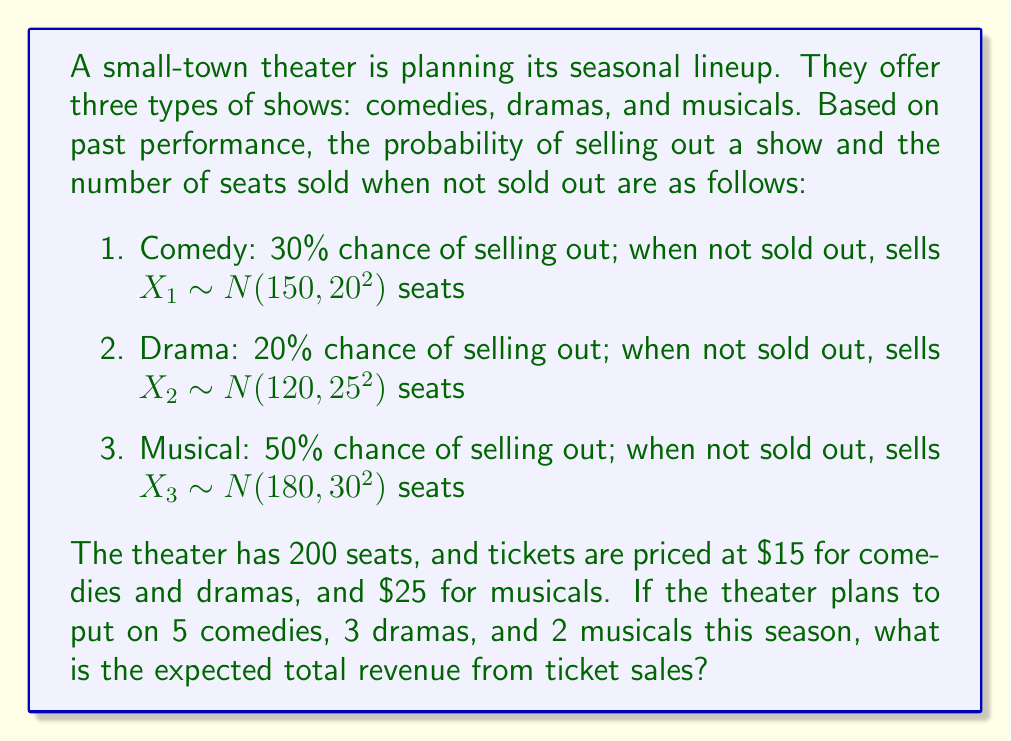Teach me how to tackle this problem. Let's approach this step-by-step:

1) First, we need to calculate the expected revenue for each type of show:

   For Comedy:
   $E(R_c) = 0.3 \cdot (200 \cdot \$15) + 0.7 \cdot (E(X_1) \cdot \$15)$
   $E(X_1) = 150$ (mean of the normal distribution)
   $E(R_c) = 0.3 \cdot \$3000 + 0.7 \cdot (150 \cdot \$15) = \$2475$

   For Drama:
   $E(R_d) = 0.2 \cdot (200 \cdot \$15) + 0.8 \cdot (E(X_2) \cdot \$15)$
   $E(X_2) = 120$
   $E(R_d) = 0.2 \cdot \$3000 + 0.8 \cdot (120 \cdot \$15) = \$2040$

   For Musical:
   $E(R_m) = 0.5 \cdot (200 \cdot \$25) + 0.5 \cdot (E(X_3) \cdot \$25)$
   $E(X_3) = 180$
   $E(R_m) = 0.5 \cdot \$5000 + 0.5 \cdot (180 \cdot \$25) = \$4750$

2) Now, we multiply each expected revenue by the number of shows:

   Comedies: $5 \cdot \$2475 = \$12,375$
   Dramas: $3 \cdot \$2040 = \$6,120$
   Musicals: $2 \cdot \$4750 = \$9,500$

3) Finally, we sum up all the revenues:

   Total Expected Revenue = $\$12,375 + \$6,120 + \$9,500 = \$27,995$
Answer: $27,995 